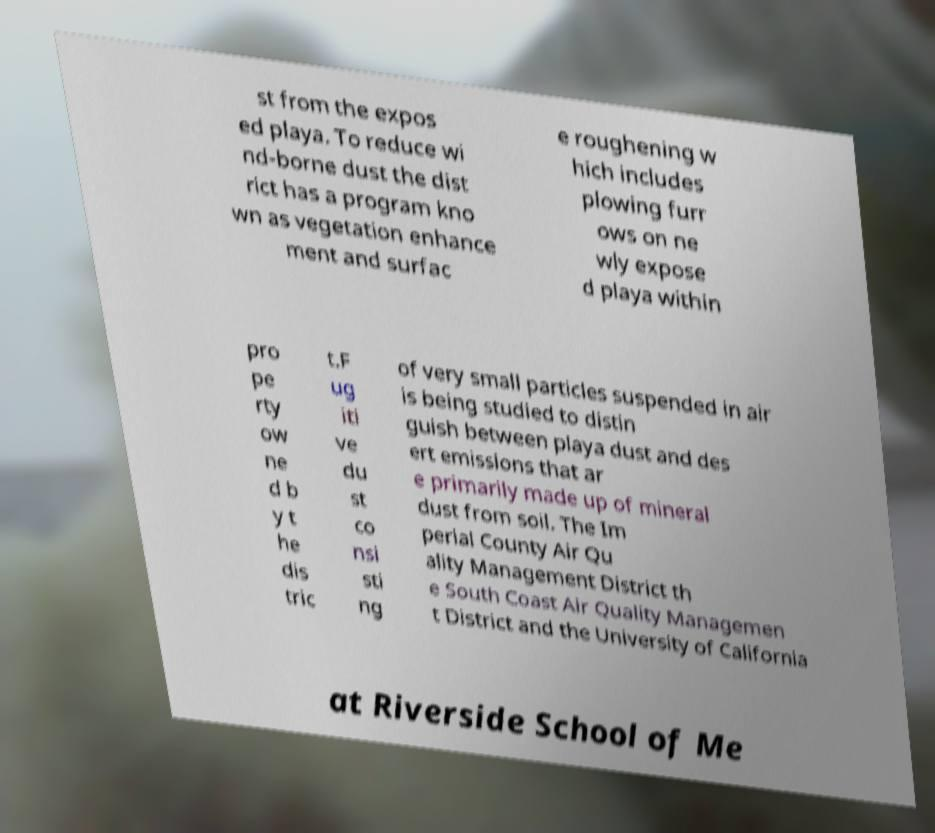I need the written content from this picture converted into text. Can you do that? st from the expos ed playa. To reduce wi nd-borne dust the dist rict has a program kno wn as vegetation enhance ment and surfac e roughening w hich includes plowing furr ows on ne wly expose d playa within pro pe rty ow ne d b y t he dis tric t.F ug iti ve du st co nsi sti ng of very small particles suspended in air is being studied to distin guish between playa dust and des ert emissions that ar e primarily made up of mineral dust from soil. The Im perial County Air Qu ality Management District th e South Coast Air Quality Managemen t District and the University of California at Riverside School of Me 